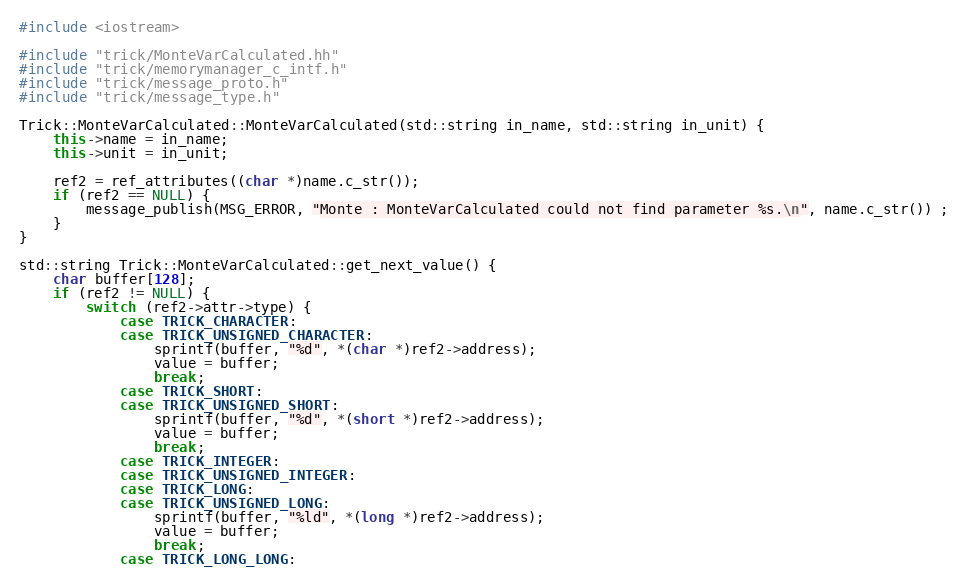<code> <loc_0><loc_0><loc_500><loc_500><_C++_>#include <iostream>

#include "trick/MonteVarCalculated.hh"
#include "trick/memorymanager_c_intf.h"
#include "trick/message_proto.h"
#include "trick/message_type.h"

Trick::MonteVarCalculated::MonteVarCalculated(std::string in_name, std::string in_unit) {
    this->name = in_name;
    this->unit = in_unit;

    ref2 = ref_attributes((char *)name.c_str());
    if (ref2 == NULL) {
        message_publish(MSG_ERROR, "Monte : MonteVarCalculated could not find parameter %s.\n", name.c_str()) ;
    }
}

std::string Trick::MonteVarCalculated::get_next_value() {
    char buffer[128];
    if (ref2 != NULL) {
        switch (ref2->attr->type) {
            case TRICK_CHARACTER:
            case TRICK_UNSIGNED_CHARACTER:
                sprintf(buffer, "%d", *(char *)ref2->address);
                value = buffer;
                break;
            case TRICK_SHORT:
            case TRICK_UNSIGNED_SHORT:
                sprintf(buffer, "%d", *(short *)ref2->address);
                value = buffer;
                break;
            case TRICK_INTEGER:
            case TRICK_UNSIGNED_INTEGER:
            case TRICK_LONG:
            case TRICK_UNSIGNED_LONG:
                sprintf(buffer, "%ld", *(long *)ref2->address);
                value = buffer;
                break;
            case TRICK_LONG_LONG:</code> 